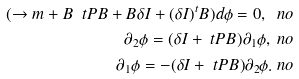Convert formula to latex. <formula><loc_0><loc_0><loc_500><loc_500>( \to m + B \ t P B + B \delta I + ( \delta I ) ^ { t } B ) d \phi = 0 , \ n o \\ \partial _ { 2 } \phi = ( \delta I + \ t P B ) \partial _ { 1 } \phi , \ n o \\ \partial _ { 1 } \phi = - ( \delta I + \ t P B ) \partial _ { 2 } \phi . \ n o</formula> 